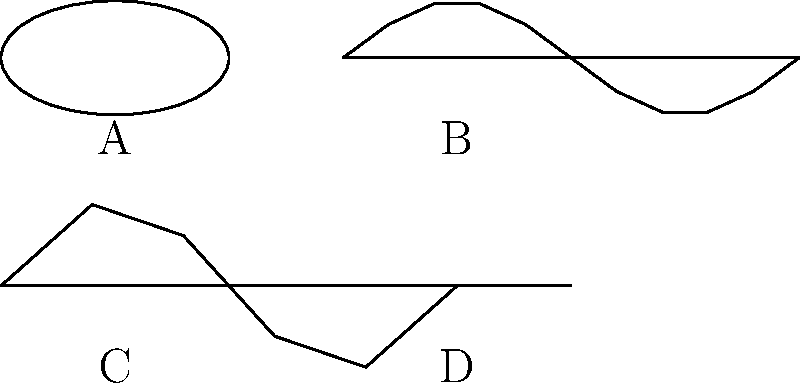Which of the leaf shapes shown is most likely to belong to a plant that produces high levels of pollen and is a common trigger for seasonal allergies? To identify the leaf shape most likely associated with a high-pollen, allergy-triggering plant, let's analyze each option:

1. Leaf A: This oval-shaped leaf with smooth edges is typical of oak trees. While oaks do produce pollen, they are not typically the most severe allergy triggers.

2. Leaf B: This serrated leaf shape is characteristic of ragweed. Ragweed is notorious for producing large amounts of highly allergenic pollen and is one of the most common triggers for seasonal allergies, especially in late summer and fall.

3. Leaf C: This lobed leaf shape is typical of maple trees. Maples do produce pollen, but they are not usually considered severe allergy triggers compared to other plants.

4. Leaf D: This needle-like leaf shape is characteristic of pine trees. While pines produce pollen, their pollen is generally less allergenic than that of many other plants.

Among these options, ragweed (Leaf B) is by far the most significant allergen producer. It's estimated that a single ragweed plant can produce up to 1 billion pollen grains in one season, and its pollen is highly allergenic, affecting up to 23 million Americans annually.
Answer: Leaf B (Ragweed) 